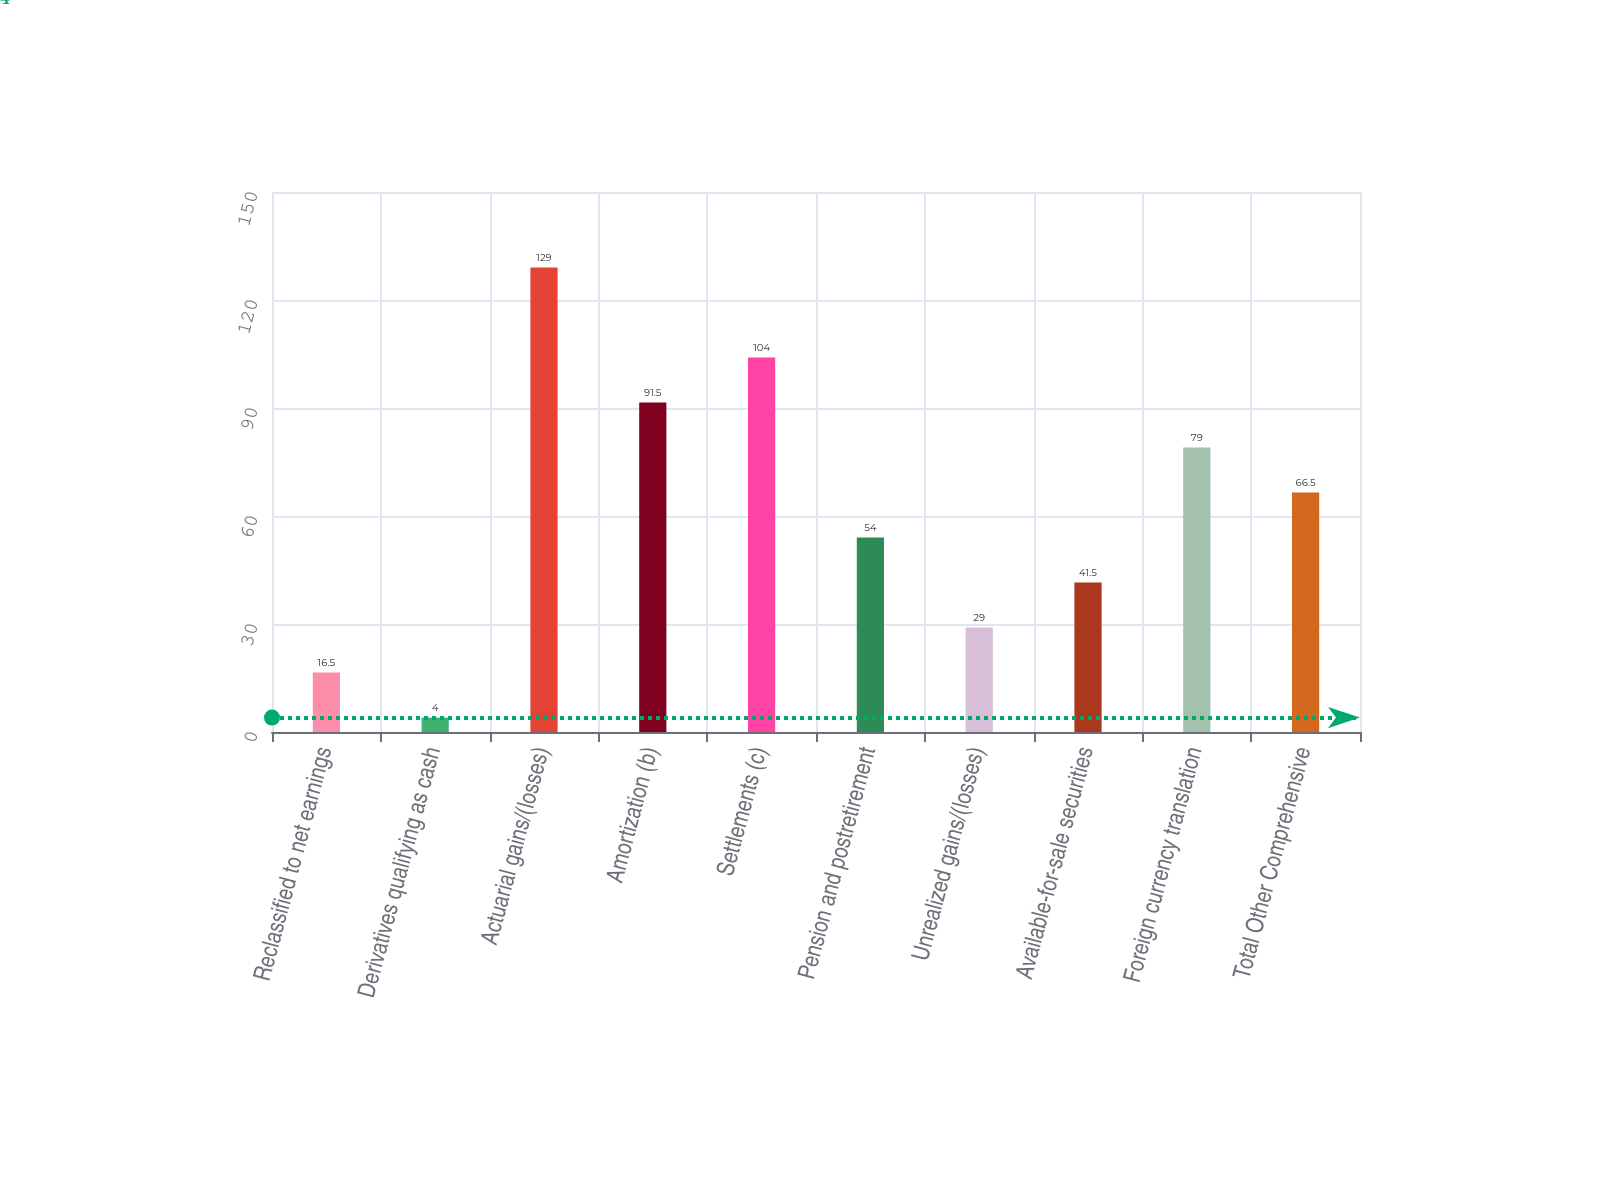Convert chart. <chart><loc_0><loc_0><loc_500><loc_500><bar_chart><fcel>Reclassified to net earnings<fcel>Derivatives qualifying as cash<fcel>Actuarial gains/(losses)<fcel>Amortization (b)<fcel>Settlements (c)<fcel>Pension and postretirement<fcel>Unrealized gains/(losses)<fcel>Available-for-sale securities<fcel>Foreign currency translation<fcel>Total Other Comprehensive<nl><fcel>16.5<fcel>4<fcel>129<fcel>91.5<fcel>104<fcel>54<fcel>29<fcel>41.5<fcel>79<fcel>66.5<nl></chart> 